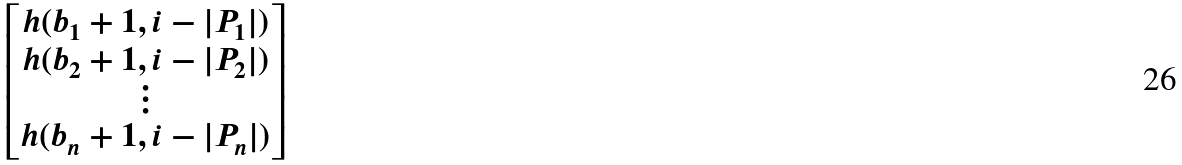<formula> <loc_0><loc_0><loc_500><loc_500>\begin{bmatrix} h ( b _ { 1 } + 1 , i - | P _ { 1 } | ) \\ h ( b _ { 2 } + 1 , i - | P _ { 2 } | ) \\ \vdots \\ h ( b _ { n } + 1 , i - | P _ { n } | ) \end{bmatrix}</formula> 